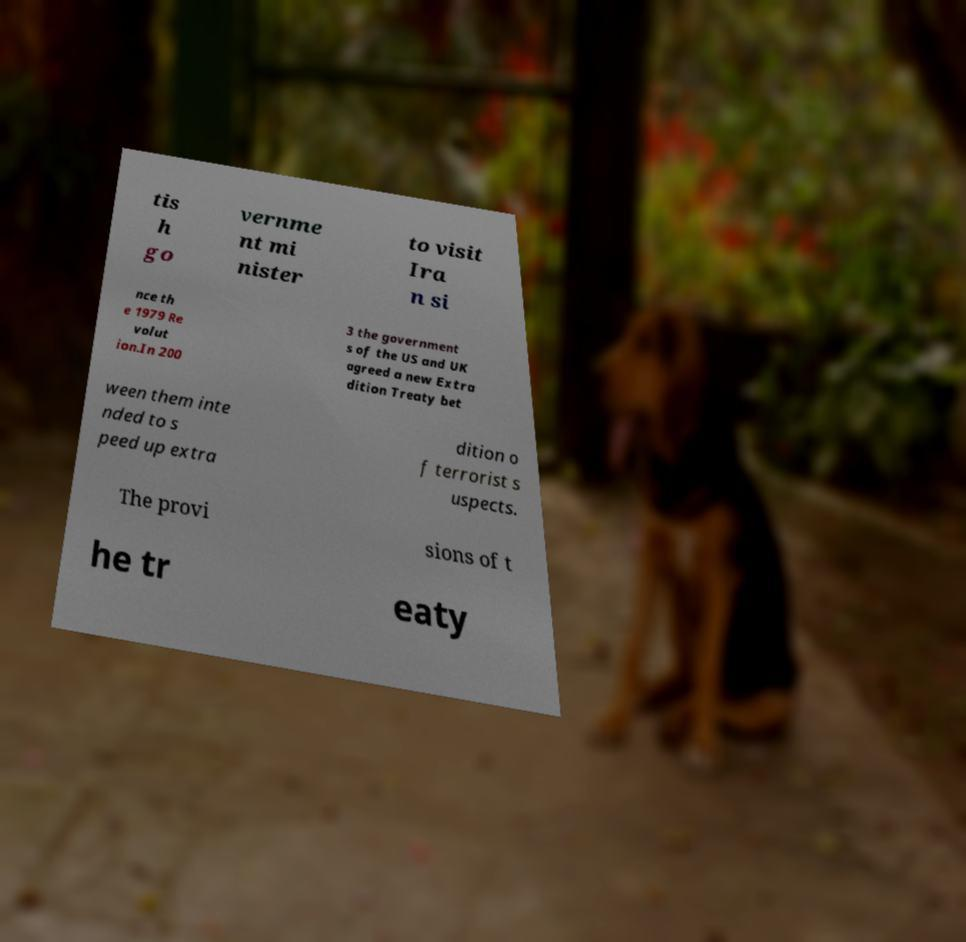Please read and relay the text visible in this image. What does it say? tis h go vernme nt mi nister to visit Ira n si nce th e 1979 Re volut ion.In 200 3 the government s of the US and UK agreed a new Extra dition Treaty bet ween them inte nded to s peed up extra dition o f terrorist s uspects. The provi sions of t he tr eaty 